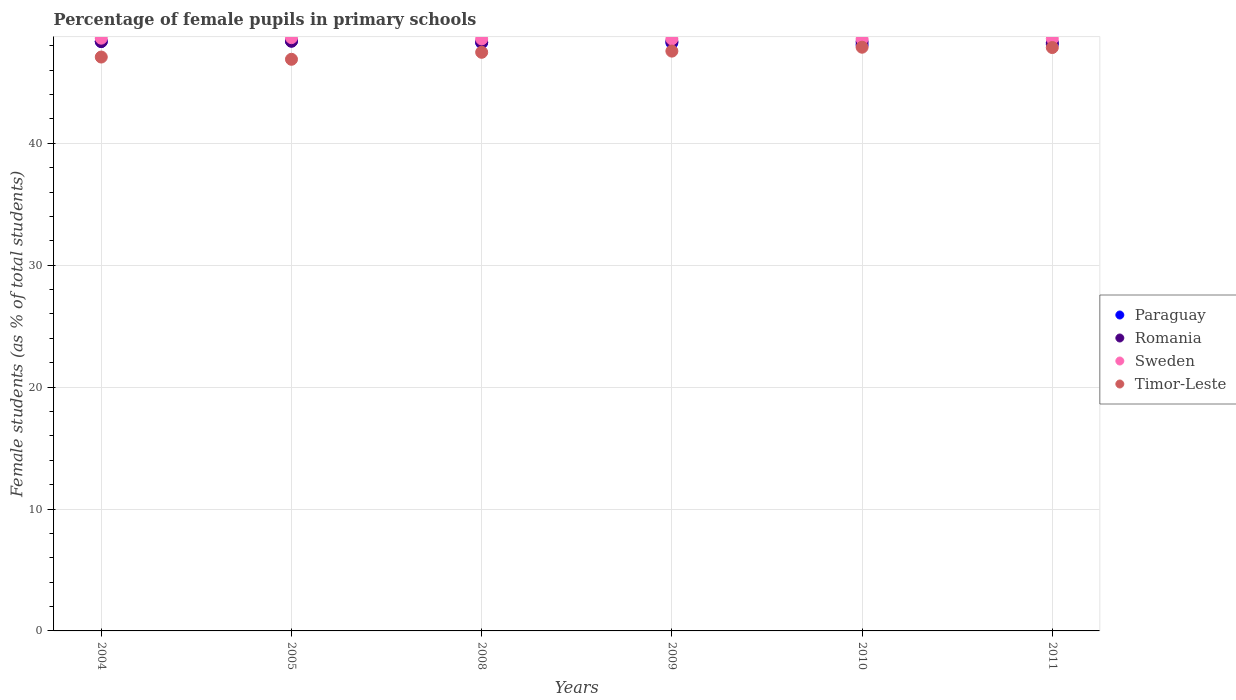What is the percentage of female pupils in primary schools in Romania in 2005?
Offer a terse response. 48.37. Across all years, what is the maximum percentage of female pupils in primary schools in Paraguay?
Give a very brief answer. 48.41. Across all years, what is the minimum percentage of female pupils in primary schools in Romania?
Make the answer very short. 48.26. In which year was the percentage of female pupils in primary schools in Paraguay minimum?
Make the answer very short. 2010. What is the total percentage of female pupils in primary schools in Timor-Leste in the graph?
Your response must be concise. 284.75. What is the difference between the percentage of female pupils in primary schools in Paraguay in 2008 and that in 2009?
Offer a terse response. 0. What is the difference between the percentage of female pupils in primary schools in Paraguay in 2005 and the percentage of female pupils in primary schools in Sweden in 2008?
Give a very brief answer. -0.16. What is the average percentage of female pupils in primary schools in Paraguay per year?
Provide a succinct answer. 48.25. In the year 2009, what is the difference between the percentage of female pupils in primary schools in Paraguay and percentage of female pupils in primary schools in Romania?
Provide a short and direct response. -0.11. What is the ratio of the percentage of female pupils in primary schools in Timor-Leste in 2004 to that in 2009?
Keep it short and to the point. 0.99. Is the percentage of female pupils in primary schools in Paraguay in 2005 less than that in 2010?
Ensure brevity in your answer.  No. What is the difference between the highest and the second highest percentage of female pupils in primary schools in Romania?
Offer a very short reply. 0.01. What is the difference between the highest and the lowest percentage of female pupils in primary schools in Sweden?
Offer a terse response. 0.11. Is the sum of the percentage of female pupils in primary schools in Sweden in 2010 and 2011 greater than the maximum percentage of female pupils in primary schools in Romania across all years?
Give a very brief answer. Yes. Is it the case that in every year, the sum of the percentage of female pupils in primary schools in Romania and percentage of female pupils in primary schools in Paraguay  is greater than the sum of percentage of female pupils in primary schools in Timor-Leste and percentage of female pupils in primary schools in Sweden?
Ensure brevity in your answer.  No. Is it the case that in every year, the sum of the percentage of female pupils in primary schools in Paraguay and percentage of female pupils in primary schools in Sweden  is greater than the percentage of female pupils in primary schools in Romania?
Provide a succinct answer. Yes. Does the percentage of female pupils in primary schools in Timor-Leste monotonically increase over the years?
Your answer should be compact. No. Is the percentage of female pupils in primary schools in Paraguay strictly less than the percentage of female pupils in primary schools in Romania over the years?
Provide a short and direct response. No. Where does the legend appear in the graph?
Your answer should be compact. Center right. How are the legend labels stacked?
Your answer should be very brief. Vertical. What is the title of the graph?
Provide a short and direct response. Percentage of female pupils in primary schools. What is the label or title of the Y-axis?
Keep it short and to the point. Female students (as % of total students). What is the Female students (as % of total students) in Paraguay in 2004?
Provide a short and direct response. 48.36. What is the Female students (as % of total students) of Romania in 2004?
Offer a very short reply. 48.35. What is the Female students (as % of total students) of Sweden in 2004?
Offer a terse response. 48.63. What is the Female students (as % of total students) in Timor-Leste in 2004?
Your response must be concise. 47.08. What is the Female students (as % of total students) of Paraguay in 2005?
Make the answer very short. 48.41. What is the Female students (as % of total students) of Romania in 2005?
Provide a succinct answer. 48.37. What is the Female students (as % of total students) in Sweden in 2005?
Provide a succinct answer. 48.67. What is the Female students (as % of total students) in Timor-Leste in 2005?
Make the answer very short. 46.89. What is the Female students (as % of total students) in Paraguay in 2008?
Provide a short and direct response. 48.26. What is the Female students (as % of total students) of Romania in 2008?
Make the answer very short. 48.31. What is the Female students (as % of total students) in Sweden in 2008?
Give a very brief answer. 48.57. What is the Female students (as % of total students) of Timor-Leste in 2008?
Offer a very short reply. 47.47. What is the Female students (as % of total students) in Paraguay in 2009?
Your answer should be compact. 48.25. What is the Female students (as % of total students) of Romania in 2009?
Ensure brevity in your answer.  48.36. What is the Female students (as % of total students) in Sweden in 2009?
Your response must be concise. 48.57. What is the Female students (as % of total students) in Timor-Leste in 2009?
Your answer should be very brief. 47.56. What is the Female students (as % of total students) of Paraguay in 2010?
Your answer should be compact. 48.08. What is the Female students (as % of total students) in Romania in 2010?
Provide a short and direct response. 48.33. What is the Female students (as % of total students) of Sweden in 2010?
Make the answer very short. 48.56. What is the Female students (as % of total students) in Timor-Leste in 2010?
Your answer should be compact. 47.88. What is the Female students (as % of total students) in Paraguay in 2011?
Make the answer very short. 48.13. What is the Female students (as % of total students) in Romania in 2011?
Ensure brevity in your answer.  48.26. What is the Female students (as % of total students) of Sweden in 2011?
Your answer should be compact. 48.59. What is the Female students (as % of total students) in Timor-Leste in 2011?
Ensure brevity in your answer.  47.86. Across all years, what is the maximum Female students (as % of total students) in Paraguay?
Offer a terse response. 48.41. Across all years, what is the maximum Female students (as % of total students) in Romania?
Make the answer very short. 48.37. Across all years, what is the maximum Female students (as % of total students) of Sweden?
Your response must be concise. 48.67. Across all years, what is the maximum Female students (as % of total students) of Timor-Leste?
Provide a short and direct response. 47.88. Across all years, what is the minimum Female students (as % of total students) of Paraguay?
Offer a terse response. 48.08. Across all years, what is the minimum Female students (as % of total students) of Romania?
Offer a very short reply. 48.26. Across all years, what is the minimum Female students (as % of total students) in Sweden?
Offer a terse response. 48.56. Across all years, what is the minimum Female students (as % of total students) of Timor-Leste?
Offer a very short reply. 46.89. What is the total Female students (as % of total students) in Paraguay in the graph?
Provide a succinct answer. 289.49. What is the total Female students (as % of total students) in Romania in the graph?
Your answer should be very brief. 289.98. What is the total Female students (as % of total students) in Sweden in the graph?
Your answer should be very brief. 291.58. What is the total Female students (as % of total students) of Timor-Leste in the graph?
Make the answer very short. 284.75. What is the difference between the Female students (as % of total students) of Paraguay in 2004 and that in 2005?
Your response must be concise. -0.05. What is the difference between the Female students (as % of total students) in Romania in 2004 and that in 2005?
Keep it short and to the point. -0.02. What is the difference between the Female students (as % of total students) in Sweden in 2004 and that in 2005?
Keep it short and to the point. -0.04. What is the difference between the Female students (as % of total students) of Timor-Leste in 2004 and that in 2005?
Your answer should be compact. 0.18. What is the difference between the Female students (as % of total students) of Paraguay in 2004 and that in 2008?
Ensure brevity in your answer.  0.1. What is the difference between the Female students (as % of total students) of Romania in 2004 and that in 2008?
Give a very brief answer. 0.04. What is the difference between the Female students (as % of total students) in Sweden in 2004 and that in 2008?
Provide a succinct answer. 0.06. What is the difference between the Female students (as % of total students) in Timor-Leste in 2004 and that in 2008?
Make the answer very short. -0.39. What is the difference between the Female students (as % of total students) in Paraguay in 2004 and that in 2009?
Make the answer very short. 0.1. What is the difference between the Female students (as % of total students) of Romania in 2004 and that in 2009?
Your answer should be very brief. -0.01. What is the difference between the Female students (as % of total students) in Sweden in 2004 and that in 2009?
Your answer should be compact. 0.06. What is the difference between the Female students (as % of total students) of Timor-Leste in 2004 and that in 2009?
Ensure brevity in your answer.  -0.49. What is the difference between the Female students (as % of total students) in Paraguay in 2004 and that in 2010?
Your response must be concise. 0.28. What is the difference between the Female students (as % of total students) in Romania in 2004 and that in 2010?
Give a very brief answer. 0.02. What is the difference between the Female students (as % of total students) of Sweden in 2004 and that in 2010?
Give a very brief answer. 0.07. What is the difference between the Female students (as % of total students) in Timor-Leste in 2004 and that in 2010?
Offer a terse response. -0.81. What is the difference between the Female students (as % of total students) in Paraguay in 2004 and that in 2011?
Offer a terse response. 0.22. What is the difference between the Female students (as % of total students) of Romania in 2004 and that in 2011?
Ensure brevity in your answer.  0.09. What is the difference between the Female students (as % of total students) of Sweden in 2004 and that in 2011?
Offer a terse response. 0.04. What is the difference between the Female students (as % of total students) in Timor-Leste in 2004 and that in 2011?
Your answer should be very brief. -0.78. What is the difference between the Female students (as % of total students) in Paraguay in 2005 and that in 2008?
Your answer should be compact. 0.15. What is the difference between the Female students (as % of total students) of Romania in 2005 and that in 2008?
Offer a terse response. 0.06. What is the difference between the Female students (as % of total students) in Sweden in 2005 and that in 2008?
Provide a short and direct response. 0.1. What is the difference between the Female students (as % of total students) in Timor-Leste in 2005 and that in 2008?
Ensure brevity in your answer.  -0.57. What is the difference between the Female students (as % of total students) in Paraguay in 2005 and that in 2009?
Keep it short and to the point. 0.15. What is the difference between the Female students (as % of total students) in Romania in 2005 and that in 2009?
Your answer should be compact. 0.01. What is the difference between the Female students (as % of total students) of Sweden in 2005 and that in 2009?
Your answer should be compact. 0.1. What is the difference between the Female students (as % of total students) of Timor-Leste in 2005 and that in 2009?
Keep it short and to the point. -0.67. What is the difference between the Female students (as % of total students) of Paraguay in 2005 and that in 2010?
Make the answer very short. 0.32. What is the difference between the Female students (as % of total students) in Romania in 2005 and that in 2010?
Provide a short and direct response. 0.05. What is the difference between the Female students (as % of total students) in Sweden in 2005 and that in 2010?
Your answer should be compact. 0.11. What is the difference between the Female students (as % of total students) in Timor-Leste in 2005 and that in 2010?
Your response must be concise. -0.99. What is the difference between the Female students (as % of total students) in Paraguay in 2005 and that in 2011?
Your response must be concise. 0.27. What is the difference between the Female students (as % of total students) in Romania in 2005 and that in 2011?
Provide a short and direct response. 0.11. What is the difference between the Female students (as % of total students) of Sweden in 2005 and that in 2011?
Provide a short and direct response. 0.08. What is the difference between the Female students (as % of total students) in Timor-Leste in 2005 and that in 2011?
Offer a terse response. -0.96. What is the difference between the Female students (as % of total students) of Paraguay in 2008 and that in 2009?
Your answer should be very brief. 0. What is the difference between the Female students (as % of total students) of Romania in 2008 and that in 2009?
Make the answer very short. -0.05. What is the difference between the Female students (as % of total students) of Sweden in 2008 and that in 2009?
Offer a very short reply. -0. What is the difference between the Female students (as % of total students) in Timor-Leste in 2008 and that in 2009?
Offer a very short reply. -0.1. What is the difference between the Female students (as % of total students) of Paraguay in 2008 and that in 2010?
Ensure brevity in your answer.  0.18. What is the difference between the Female students (as % of total students) in Romania in 2008 and that in 2010?
Your answer should be very brief. -0.02. What is the difference between the Female students (as % of total students) in Sweden in 2008 and that in 2010?
Provide a succinct answer. 0.01. What is the difference between the Female students (as % of total students) in Timor-Leste in 2008 and that in 2010?
Offer a very short reply. -0.42. What is the difference between the Female students (as % of total students) of Paraguay in 2008 and that in 2011?
Your answer should be compact. 0.12. What is the difference between the Female students (as % of total students) of Romania in 2008 and that in 2011?
Provide a succinct answer. 0.05. What is the difference between the Female students (as % of total students) of Sweden in 2008 and that in 2011?
Provide a short and direct response. -0.02. What is the difference between the Female students (as % of total students) in Timor-Leste in 2008 and that in 2011?
Offer a very short reply. -0.39. What is the difference between the Female students (as % of total students) of Paraguay in 2009 and that in 2010?
Provide a short and direct response. 0.17. What is the difference between the Female students (as % of total students) in Romania in 2009 and that in 2010?
Make the answer very short. 0.04. What is the difference between the Female students (as % of total students) in Sweden in 2009 and that in 2010?
Keep it short and to the point. 0.01. What is the difference between the Female students (as % of total students) of Timor-Leste in 2009 and that in 2010?
Keep it short and to the point. -0.32. What is the difference between the Female students (as % of total students) in Paraguay in 2009 and that in 2011?
Provide a succinct answer. 0.12. What is the difference between the Female students (as % of total students) of Romania in 2009 and that in 2011?
Your response must be concise. 0.1. What is the difference between the Female students (as % of total students) in Sweden in 2009 and that in 2011?
Give a very brief answer. -0.02. What is the difference between the Female students (as % of total students) in Timor-Leste in 2009 and that in 2011?
Offer a terse response. -0.29. What is the difference between the Female students (as % of total students) of Paraguay in 2010 and that in 2011?
Provide a succinct answer. -0.05. What is the difference between the Female students (as % of total students) in Romania in 2010 and that in 2011?
Your answer should be compact. 0.07. What is the difference between the Female students (as % of total students) of Sweden in 2010 and that in 2011?
Provide a succinct answer. -0.03. What is the difference between the Female students (as % of total students) of Timor-Leste in 2010 and that in 2011?
Provide a succinct answer. 0.03. What is the difference between the Female students (as % of total students) in Paraguay in 2004 and the Female students (as % of total students) in Romania in 2005?
Provide a succinct answer. -0.01. What is the difference between the Female students (as % of total students) in Paraguay in 2004 and the Female students (as % of total students) in Sweden in 2005?
Your answer should be very brief. -0.31. What is the difference between the Female students (as % of total students) in Paraguay in 2004 and the Female students (as % of total students) in Timor-Leste in 2005?
Give a very brief answer. 1.46. What is the difference between the Female students (as % of total students) of Romania in 2004 and the Female students (as % of total students) of Sweden in 2005?
Provide a succinct answer. -0.32. What is the difference between the Female students (as % of total students) of Romania in 2004 and the Female students (as % of total students) of Timor-Leste in 2005?
Your answer should be compact. 1.46. What is the difference between the Female students (as % of total students) of Sweden in 2004 and the Female students (as % of total students) of Timor-Leste in 2005?
Provide a short and direct response. 1.73. What is the difference between the Female students (as % of total students) in Paraguay in 2004 and the Female students (as % of total students) in Romania in 2008?
Your answer should be compact. 0.05. What is the difference between the Female students (as % of total students) of Paraguay in 2004 and the Female students (as % of total students) of Sweden in 2008?
Your response must be concise. -0.21. What is the difference between the Female students (as % of total students) in Paraguay in 2004 and the Female students (as % of total students) in Timor-Leste in 2008?
Provide a short and direct response. 0.89. What is the difference between the Female students (as % of total students) of Romania in 2004 and the Female students (as % of total students) of Sweden in 2008?
Your answer should be very brief. -0.22. What is the difference between the Female students (as % of total students) in Romania in 2004 and the Female students (as % of total students) in Timor-Leste in 2008?
Ensure brevity in your answer.  0.88. What is the difference between the Female students (as % of total students) in Sweden in 2004 and the Female students (as % of total students) in Timor-Leste in 2008?
Make the answer very short. 1.16. What is the difference between the Female students (as % of total students) of Paraguay in 2004 and the Female students (as % of total students) of Romania in 2009?
Your answer should be compact. -0.01. What is the difference between the Female students (as % of total students) of Paraguay in 2004 and the Female students (as % of total students) of Sweden in 2009?
Provide a short and direct response. -0.21. What is the difference between the Female students (as % of total students) in Paraguay in 2004 and the Female students (as % of total students) in Timor-Leste in 2009?
Provide a succinct answer. 0.79. What is the difference between the Female students (as % of total students) of Romania in 2004 and the Female students (as % of total students) of Sweden in 2009?
Offer a very short reply. -0.22. What is the difference between the Female students (as % of total students) in Romania in 2004 and the Female students (as % of total students) in Timor-Leste in 2009?
Your response must be concise. 0.78. What is the difference between the Female students (as % of total students) in Sweden in 2004 and the Female students (as % of total students) in Timor-Leste in 2009?
Provide a short and direct response. 1.06. What is the difference between the Female students (as % of total students) in Paraguay in 2004 and the Female students (as % of total students) in Romania in 2010?
Ensure brevity in your answer.  0.03. What is the difference between the Female students (as % of total students) of Paraguay in 2004 and the Female students (as % of total students) of Sweden in 2010?
Offer a very short reply. -0.2. What is the difference between the Female students (as % of total students) of Paraguay in 2004 and the Female students (as % of total students) of Timor-Leste in 2010?
Your response must be concise. 0.47. What is the difference between the Female students (as % of total students) in Romania in 2004 and the Female students (as % of total students) in Sweden in 2010?
Your response must be concise. -0.21. What is the difference between the Female students (as % of total students) in Romania in 2004 and the Female students (as % of total students) in Timor-Leste in 2010?
Your answer should be very brief. 0.46. What is the difference between the Female students (as % of total students) in Sweden in 2004 and the Female students (as % of total students) in Timor-Leste in 2010?
Ensure brevity in your answer.  0.74. What is the difference between the Female students (as % of total students) of Paraguay in 2004 and the Female students (as % of total students) of Romania in 2011?
Make the answer very short. 0.1. What is the difference between the Female students (as % of total students) in Paraguay in 2004 and the Female students (as % of total students) in Sweden in 2011?
Make the answer very short. -0.23. What is the difference between the Female students (as % of total students) of Paraguay in 2004 and the Female students (as % of total students) of Timor-Leste in 2011?
Your answer should be compact. 0.5. What is the difference between the Female students (as % of total students) of Romania in 2004 and the Female students (as % of total students) of Sweden in 2011?
Offer a very short reply. -0.24. What is the difference between the Female students (as % of total students) of Romania in 2004 and the Female students (as % of total students) of Timor-Leste in 2011?
Your answer should be compact. 0.49. What is the difference between the Female students (as % of total students) of Sweden in 2004 and the Female students (as % of total students) of Timor-Leste in 2011?
Your answer should be very brief. 0.77. What is the difference between the Female students (as % of total students) of Paraguay in 2005 and the Female students (as % of total students) of Romania in 2008?
Provide a short and direct response. 0.1. What is the difference between the Female students (as % of total students) of Paraguay in 2005 and the Female students (as % of total students) of Sweden in 2008?
Provide a succinct answer. -0.16. What is the difference between the Female students (as % of total students) in Paraguay in 2005 and the Female students (as % of total students) in Timor-Leste in 2008?
Your answer should be compact. 0.94. What is the difference between the Female students (as % of total students) in Romania in 2005 and the Female students (as % of total students) in Sweden in 2008?
Keep it short and to the point. -0.19. What is the difference between the Female students (as % of total students) in Romania in 2005 and the Female students (as % of total students) in Timor-Leste in 2008?
Your answer should be compact. 0.9. What is the difference between the Female students (as % of total students) in Sweden in 2005 and the Female students (as % of total students) in Timor-Leste in 2008?
Give a very brief answer. 1.2. What is the difference between the Female students (as % of total students) in Paraguay in 2005 and the Female students (as % of total students) in Romania in 2009?
Provide a short and direct response. 0.04. What is the difference between the Female students (as % of total students) in Paraguay in 2005 and the Female students (as % of total students) in Sweden in 2009?
Ensure brevity in your answer.  -0.16. What is the difference between the Female students (as % of total students) in Paraguay in 2005 and the Female students (as % of total students) in Timor-Leste in 2009?
Ensure brevity in your answer.  0.84. What is the difference between the Female students (as % of total students) in Romania in 2005 and the Female students (as % of total students) in Sweden in 2009?
Offer a very short reply. -0.2. What is the difference between the Female students (as % of total students) in Romania in 2005 and the Female students (as % of total students) in Timor-Leste in 2009?
Make the answer very short. 0.81. What is the difference between the Female students (as % of total students) of Sweden in 2005 and the Female students (as % of total students) of Timor-Leste in 2009?
Keep it short and to the point. 1.1. What is the difference between the Female students (as % of total students) in Paraguay in 2005 and the Female students (as % of total students) in Romania in 2010?
Give a very brief answer. 0.08. What is the difference between the Female students (as % of total students) in Paraguay in 2005 and the Female students (as % of total students) in Sweden in 2010?
Offer a very short reply. -0.15. What is the difference between the Female students (as % of total students) in Paraguay in 2005 and the Female students (as % of total students) in Timor-Leste in 2010?
Provide a short and direct response. 0.52. What is the difference between the Female students (as % of total students) of Romania in 2005 and the Female students (as % of total students) of Sweden in 2010?
Provide a short and direct response. -0.19. What is the difference between the Female students (as % of total students) in Romania in 2005 and the Female students (as % of total students) in Timor-Leste in 2010?
Make the answer very short. 0.49. What is the difference between the Female students (as % of total students) in Sweden in 2005 and the Female students (as % of total students) in Timor-Leste in 2010?
Offer a terse response. 0.78. What is the difference between the Female students (as % of total students) in Paraguay in 2005 and the Female students (as % of total students) in Romania in 2011?
Offer a terse response. 0.14. What is the difference between the Female students (as % of total students) in Paraguay in 2005 and the Female students (as % of total students) in Sweden in 2011?
Keep it short and to the point. -0.18. What is the difference between the Female students (as % of total students) of Paraguay in 2005 and the Female students (as % of total students) of Timor-Leste in 2011?
Provide a succinct answer. 0.55. What is the difference between the Female students (as % of total students) of Romania in 2005 and the Female students (as % of total students) of Sweden in 2011?
Offer a very short reply. -0.22. What is the difference between the Female students (as % of total students) of Romania in 2005 and the Female students (as % of total students) of Timor-Leste in 2011?
Make the answer very short. 0.51. What is the difference between the Female students (as % of total students) of Sweden in 2005 and the Female students (as % of total students) of Timor-Leste in 2011?
Your response must be concise. 0.81. What is the difference between the Female students (as % of total students) of Paraguay in 2008 and the Female students (as % of total students) of Romania in 2009?
Give a very brief answer. -0.11. What is the difference between the Female students (as % of total students) of Paraguay in 2008 and the Female students (as % of total students) of Sweden in 2009?
Your answer should be compact. -0.31. What is the difference between the Female students (as % of total students) of Paraguay in 2008 and the Female students (as % of total students) of Timor-Leste in 2009?
Your response must be concise. 0.69. What is the difference between the Female students (as % of total students) in Romania in 2008 and the Female students (as % of total students) in Sweden in 2009?
Provide a succinct answer. -0.26. What is the difference between the Female students (as % of total students) of Romania in 2008 and the Female students (as % of total students) of Timor-Leste in 2009?
Offer a terse response. 0.75. What is the difference between the Female students (as % of total students) in Paraguay in 2008 and the Female students (as % of total students) in Romania in 2010?
Offer a terse response. -0.07. What is the difference between the Female students (as % of total students) in Paraguay in 2008 and the Female students (as % of total students) in Sweden in 2010?
Offer a very short reply. -0.3. What is the difference between the Female students (as % of total students) of Paraguay in 2008 and the Female students (as % of total students) of Timor-Leste in 2010?
Make the answer very short. 0.37. What is the difference between the Female students (as % of total students) in Romania in 2008 and the Female students (as % of total students) in Sweden in 2010?
Provide a succinct answer. -0.25. What is the difference between the Female students (as % of total students) in Romania in 2008 and the Female students (as % of total students) in Timor-Leste in 2010?
Give a very brief answer. 0.43. What is the difference between the Female students (as % of total students) in Sweden in 2008 and the Female students (as % of total students) in Timor-Leste in 2010?
Offer a very short reply. 0.68. What is the difference between the Female students (as % of total students) in Paraguay in 2008 and the Female students (as % of total students) in Romania in 2011?
Offer a very short reply. -0. What is the difference between the Female students (as % of total students) in Paraguay in 2008 and the Female students (as % of total students) in Timor-Leste in 2011?
Keep it short and to the point. 0.4. What is the difference between the Female students (as % of total students) in Romania in 2008 and the Female students (as % of total students) in Sweden in 2011?
Your response must be concise. -0.28. What is the difference between the Female students (as % of total students) of Romania in 2008 and the Female students (as % of total students) of Timor-Leste in 2011?
Your answer should be very brief. 0.45. What is the difference between the Female students (as % of total students) in Sweden in 2008 and the Female students (as % of total students) in Timor-Leste in 2011?
Your answer should be very brief. 0.71. What is the difference between the Female students (as % of total students) of Paraguay in 2009 and the Female students (as % of total students) of Romania in 2010?
Offer a terse response. -0.07. What is the difference between the Female students (as % of total students) of Paraguay in 2009 and the Female students (as % of total students) of Sweden in 2010?
Your response must be concise. -0.31. What is the difference between the Female students (as % of total students) of Paraguay in 2009 and the Female students (as % of total students) of Timor-Leste in 2010?
Ensure brevity in your answer.  0.37. What is the difference between the Female students (as % of total students) in Romania in 2009 and the Female students (as % of total students) in Sweden in 2010?
Offer a very short reply. -0.2. What is the difference between the Female students (as % of total students) in Romania in 2009 and the Female students (as % of total students) in Timor-Leste in 2010?
Offer a very short reply. 0.48. What is the difference between the Female students (as % of total students) in Sweden in 2009 and the Female students (as % of total students) in Timor-Leste in 2010?
Offer a very short reply. 0.68. What is the difference between the Female students (as % of total students) of Paraguay in 2009 and the Female students (as % of total students) of Romania in 2011?
Make the answer very short. -0.01. What is the difference between the Female students (as % of total students) in Paraguay in 2009 and the Female students (as % of total students) in Sweden in 2011?
Make the answer very short. -0.34. What is the difference between the Female students (as % of total students) of Paraguay in 2009 and the Female students (as % of total students) of Timor-Leste in 2011?
Give a very brief answer. 0.4. What is the difference between the Female students (as % of total students) in Romania in 2009 and the Female students (as % of total students) in Sweden in 2011?
Offer a terse response. -0.23. What is the difference between the Female students (as % of total students) of Romania in 2009 and the Female students (as % of total students) of Timor-Leste in 2011?
Your answer should be very brief. 0.51. What is the difference between the Female students (as % of total students) of Sweden in 2009 and the Female students (as % of total students) of Timor-Leste in 2011?
Your response must be concise. 0.71. What is the difference between the Female students (as % of total students) in Paraguay in 2010 and the Female students (as % of total students) in Romania in 2011?
Keep it short and to the point. -0.18. What is the difference between the Female students (as % of total students) in Paraguay in 2010 and the Female students (as % of total students) in Sweden in 2011?
Ensure brevity in your answer.  -0.51. What is the difference between the Female students (as % of total students) of Paraguay in 2010 and the Female students (as % of total students) of Timor-Leste in 2011?
Offer a very short reply. 0.22. What is the difference between the Female students (as % of total students) of Romania in 2010 and the Female students (as % of total students) of Sweden in 2011?
Your answer should be compact. -0.26. What is the difference between the Female students (as % of total students) in Romania in 2010 and the Female students (as % of total students) in Timor-Leste in 2011?
Keep it short and to the point. 0.47. What is the difference between the Female students (as % of total students) of Sweden in 2010 and the Female students (as % of total students) of Timor-Leste in 2011?
Ensure brevity in your answer.  0.7. What is the average Female students (as % of total students) in Paraguay per year?
Offer a very short reply. 48.25. What is the average Female students (as % of total students) of Romania per year?
Provide a short and direct response. 48.33. What is the average Female students (as % of total students) in Sweden per year?
Keep it short and to the point. 48.6. What is the average Female students (as % of total students) of Timor-Leste per year?
Ensure brevity in your answer.  47.46. In the year 2004, what is the difference between the Female students (as % of total students) of Paraguay and Female students (as % of total students) of Romania?
Provide a succinct answer. 0.01. In the year 2004, what is the difference between the Female students (as % of total students) of Paraguay and Female students (as % of total students) of Sweden?
Give a very brief answer. -0.27. In the year 2004, what is the difference between the Female students (as % of total students) in Paraguay and Female students (as % of total students) in Timor-Leste?
Offer a very short reply. 1.28. In the year 2004, what is the difference between the Female students (as % of total students) in Romania and Female students (as % of total students) in Sweden?
Your response must be concise. -0.28. In the year 2004, what is the difference between the Female students (as % of total students) of Romania and Female students (as % of total students) of Timor-Leste?
Your answer should be compact. 1.27. In the year 2004, what is the difference between the Female students (as % of total students) in Sweden and Female students (as % of total students) in Timor-Leste?
Ensure brevity in your answer.  1.55. In the year 2005, what is the difference between the Female students (as % of total students) in Paraguay and Female students (as % of total students) in Romania?
Ensure brevity in your answer.  0.03. In the year 2005, what is the difference between the Female students (as % of total students) of Paraguay and Female students (as % of total students) of Sweden?
Your answer should be compact. -0.26. In the year 2005, what is the difference between the Female students (as % of total students) in Paraguay and Female students (as % of total students) in Timor-Leste?
Keep it short and to the point. 1.51. In the year 2005, what is the difference between the Female students (as % of total students) of Romania and Female students (as % of total students) of Sweden?
Keep it short and to the point. -0.3. In the year 2005, what is the difference between the Female students (as % of total students) in Romania and Female students (as % of total students) in Timor-Leste?
Your response must be concise. 1.48. In the year 2005, what is the difference between the Female students (as % of total students) of Sweden and Female students (as % of total students) of Timor-Leste?
Provide a succinct answer. 1.77. In the year 2008, what is the difference between the Female students (as % of total students) of Paraguay and Female students (as % of total students) of Romania?
Offer a terse response. -0.05. In the year 2008, what is the difference between the Female students (as % of total students) in Paraguay and Female students (as % of total students) in Sweden?
Offer a terse response. -0.31. In the year 2008, what is the difference between the Female students (as % of total students) of Paraguay and Female students (as % of total students) of Timor-Leste?
Make the answer very short. 0.79. In the year 2008, what is the difference between the Female students (as % of total students) of Romania and Female students (as % of total students) of Sweden?
Offer a very short reply. -0.26. In the year 2008, what is the difference between the Female students (as % of total students) in Romania and Female students (as % of total students) in Timor-Leste?
Offer a terse response. 0.84. In the year 2008, what is the difference between the Female students (as % of total students) in Sweden and Female students (as % of total students) in Timor-Leste?
Offer a very short reply. 1.1. In the year 2009, what is the difference between the Female students (as % of total students) of Paraguay and Female students (as % of total students) of Romania?
Give a very brief answer. -0.11. In the year 2009, what is the difference between the Female students (as % of total students) in Paraguay and Female students (as % of total students) in Sweden?
Ensure brevity in your answer.  -0.31. In the year 2009, what is the difference between the Female students (as % of total students) of Paraguay and Female students (as % of total students) of Timor-Leste?
Provide a short and direct response. 0.69. In the year 2009, what is the difference between the Female students (as % of total students) in Romania and Female students (as % of total students) in Sweden?
Provide a succinct answer. -0.2. In the year 2009, what is the difference between the Female students (as % of total students) of Romania and Female students (as % of total students) of Timor-Leste?
Provide a succinct answer. 0.8. In the year 2010, what is the difference between the Female students (as % of total students) in Paraguay and Female students (as % of total students) in Romania?
Provide a short and direct response. -0.24. In the year 2010, what is the difference between the Female students (as % of total students) in Paraguay and Female students (as % of total students) in Sweden?
Your answer should be very brief. -0.48. In the year 2010, what is the difference between the Female students (as % of total students) in Paraguay and Female students (as % of total students) in Timor-Leste?
Give a very brief answer. 0.2. In the year 2010, what is the difference between the Female students (as % of total students) of Romania and Female students (as % of total students) of Sweden?
Keep it short and to the point. -0.23. In the year 2010, what is the difference between the Female students (as % of total students) in Romania and Female students (as % of total students) in Timor-Leste?
Keep it short and to the point. 0.44. In the year 2010, what is the difference between the Female students (as % of total students) of Sweden and Female students (as % of total students) of Timor-Leste?
Provide a short and direct response. 0.67. In the year 2011, what is the difference between the Female students (as % of total students) in Paraguay and Female students (as % of total students) in Romania?
Provide a succinct answer. -0.13. In the year 2011, what is the difference between the Female students (as % of total students) of Paraguay and Female students (as % of total students) of Sweden?
Offer a terse response. -0.46. In the year 2011, what is the difference between the Female students (as % of total students) in Paraguay and Female students (as % of total students) in Timor-Leste?
Your answer should be compact. 0.28. In the year 2011, what is the difference between the Female students (as % of total students) in Romania and Female students (as % of total students) in Sweden?
Provide a short and direct response. -0.33. In the year 2011, what is the difference between the Female students (as % of total students) in Romania and Female students (as % of total students) in Timor-Leste?
Provide a succinct answer. 0.4. In the year 2011, what is the difference between the Female students (as % of total students) in Sweden and Female students (as % of total students) in Timor-Leste?
Ensure brevity in your answer.  0.73. What is the ratio of the Female students (as % of total students) of Paraguay in 2004 to that in 2005?
Provide a short and direct response. 1. What is the ratio of the Female students (as % of total students) in Sweden in 2004 to that in 2005?
Provide a short and direct response. 1. What is the ratio of the Female students (as % of total students) in Timor-Leste in 2004 to that in 2005?
Give a very brief answer. 1. What is the ratio of the Female students (as % of total students) in Timor-Leste in 2004 to that in 2008?
Offer a terse response. 0.99. What is the ratio of the Female students (as % of total students) of Paraguay in 2004 to that in 2009?
Offer a very short reply. 1. What is the ratio of the Female students (as % of total students) in Sweden in 2004 to that in 2009?
Your answer should be very brief. 1. What is the ratio of the Female students (as % of total students) of Timor-Leste in 2004 to that in 2009?
Your answer should be very brief. 0.99. What is the ratio of the Female students (as % of total students) of Romania in 2004 to that in 2010?
Your answer should be compact. 1. What is the ratio of the Female students (as % of total students) of Sweden in 2004 to that in 2010?
Make the answer very short. 1. What is the ratio of the Female students (as % of total students) in Timor-Leste in 2004 to that in 2010?
Provide a short and direct response. 0.98. What is the ratio of the Female students (as % of total students) of Paraguay in 2004 to that in 2011?
Offer a very short reply. 1. What is the ratio of the Female students (as % of total students) in Sweden in 2004 to that in 2011?
Ensure brevity in your answer.  1. What is the ratio of the Female students (as % of total students) of Timor-Leste in 2004 to that in 2011?
Your answer should be very brief. 0.98. What is the ratio of the Female students (as % of total students) in Timor-Leste in 2005 to that in 2008?
Offer a very short reply. 0.99. What is the ratio of the Female students (as % of total students) of Timor-Leste in 2005 to that in 2009?
Give a very brief answer. 0.99. What is the ratio of the Female students (as % of total students) of Timor-Leste in 2005 to that in 2010?
Offer a terse response. 0.98. What is the ratio of the Female students (as % of total students) of Timor-Leste in 2005 to that in 2011?
Offer a terse response. 0.98. What is the ratio of the Female students (as % of total students) in Paraguay in 2008 to that in 2009?
Your answer should be very brief. 1. What is the ratio of the Female students (as % of total students) in Timor-Leste in 2008 to that in 2009?
Provide a short and direct response. 1. What is the ratio of the Female students (as % of total students) of Romania in 2008 to that in 2010?
Make the answer very short. 1. What is the ratio of the Female students (as % of total students) in Romania in 2008 to that in 2011?
Your answer should be compact. 1. What is the ratio of the Female students (as % of total students) in Sweden in 2008 to that in 2011?
Offer a very short reply. 1. What is the ratio of the Female students (as % of total students) in Paraguay in 2009 to that in 2010?
Offer a very short reply. 1. What is the ratio of the Female students (as % of total students) of Romania in 2009 to that in 2010?
Provide a succinct answer. 1. What is the ratio of the Female students (as % of total students) in Sweden in 2009 to that in 2010?
Your response must be concise. 1. What is the ratio of the Female students (as % of total students) of Romania in 2009 to that in 2011?
Provide a succinct answer. 1. What is the ratio of the Female students (as % of total students) in Sweden in 2009 to that in 2011?
Your answer should be compact. 1. What is the ratio of the Female students (as % of total students) of Timor-Leste in 2009 to that in 2011?
Give a very brief answer. 0.99. What is the ratio of the Female students (as % of total students) of Paraguay in 2010 to that in 2011?
Provide a succinct answer. 1. What is the ratio of the Female students (as % of total students) in Romania in 2010 to that in 2011?
Keep it short and to the point. 1. What is the ratio of the Female students (as % of total students) of Sweden in 2010 to that in 2011?
Your answer should be very brief. 1. What is the ratio of the Female students (as % of total students) of Timor-Leste in 2010 to that in 2011?
Your response must be concise. 1. What is the difference between the highest and the second highest Female students (as % of total students) in Paraguay?
Offer a very short reply. 0.05. What is the difference between the highest and the second highest Female students (as % of total students) in Romania?
Your answer should be compact. 0.01. What is the difference between the highest and the second highest Female students (as % of total students) in Sweden?
Provide a succinct answer. 0.04. What is the difference between the highest and the second highest Female students (as % of total students) in Timor-Leste?
Your answer should be very brief. 0.03. What is the difference between the highest and the lowest Female students (as % of total students) in Paraguay?
Make the answer very short. 0.32. What is the difference between the highest and the lowest Female students (as % of total students) of Romania?
Make the answer very short. 0.11. What is the difference between the highest and the lowest Female students (as % of total students) in Sweden?
Offer a terse response. 0.11. What is the difference between the highest and the lowest Female students (as % of total students) of Timor-Leste?
Offer a terse response. 0.99. 